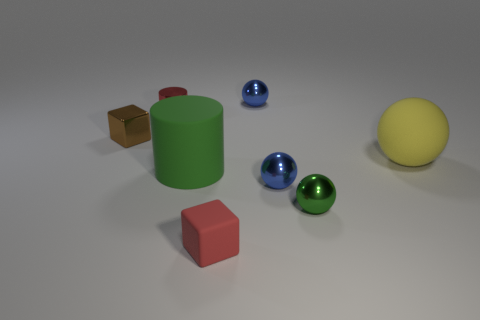What color is the tiny cube that is on the right side of the small cube that is behind the small red thing on the right side of the red metal cylinder?
Your answer should be compact. Red. What number of other big spheres are the same color as the big ball?
Offer a very short reply. 0. How many small things are metallic things or spheres?
Ensure brevity in your answer.  5. Is there a yellow matte object of the same shape as the small red metal thing?
Provide a short and direct response. No. Is the shape of the red metallic object the same as the brown metallic object?
Keep it short and to the point. No. The large matte thing to the left of the tiny metal sphere behind the large green rubber cylinder is what color?
Keep it short and to the point. Green. The thing that is the same size as the green matte cylinder is what color?
Make the answer very short. Yellow. What number of matte things are brown objects or blue balls?
Give a very brief answer. 0. There is a red shiny object behind the large green cylinder; how many blue metal spheres are in front of it?
Provide a short and direct response. 1. There is a object that is the same color as the big cylinder; what is its size?
Your answer should be very brief. Small. 